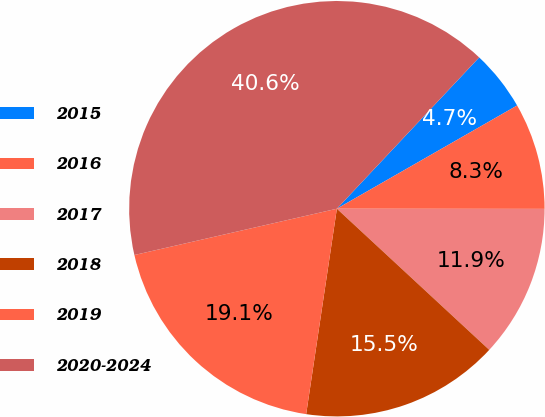Convert chart to OTSL. <chart><loc_0><loc_0><loc_500><loc_500><pie_chart><fcel>2015<fcel>2016<fcel>2017<fcel>2018<fcel>2019<fcel>2020-2024<nl><fcel>4.71%<fcel>8.29%<fcel>11.88%<fcel>15.47%<fcel>19.06%<fcel>40.59%<nl></chart> 